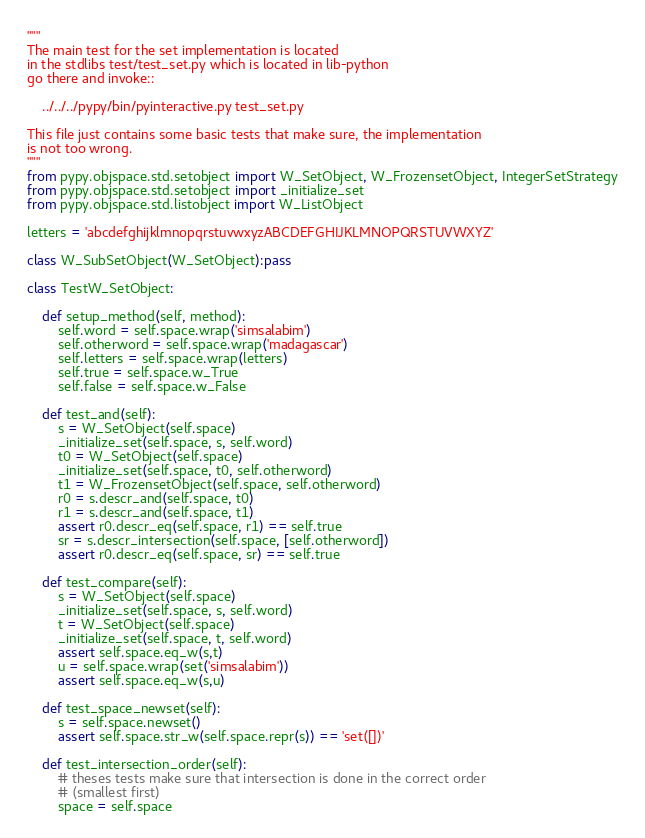Convert code to text. <code><loc_0><loc_0><loc_500><loc_500><_Python_>"""
The main test for the set implementation is located
in the stdlibs test/test_set.py which is located in lib-python
go there and invoke::

    ../../../pypy/bin/pyinteractive.py test_set.py

This file just contains some basic tests that make sure, the implementation
is not too wrong.
"""
from pypy.objspace.std.setobject import W_SetObject, W_FrozensetObject, IntegerSetStrategy
from pypy.objspace.std.setobject import _initialize_set
from pypy.objspace.std.listobject import W_ListObject

letters = 'abcdefghijklmnopqrstuvwxyzABCDEFGHIJKLMNOPQRSTUVWXYZ'

class W_SubSetObject(W_SetObject):pass

class TestW_SetObject:

    def setup_method(self, method):
        self.word = self.space.wrap('simsalabim')
        self.otherword = self.space.wrap('madagascar')
        self.letters = self.space.wrap(letters)
        self.true = self.space.w_True
        self.false = self.space.w_False

    def test_and(self):
        s = W_SetObject(self.space)
        _initialize_set(self.space, s, self.word)
        t0 = W_SetObject(self.space)
        _initialize_set(self.space, t0, self.otherword)
        t1 = W_FrozensetObject(self.space, self.otherword)
        r0 = s.descr_and(self.space, t0)
        r1 = s.descr_and(self.space, t1)
        assert r0.descr_eq(self.space, r1) == self.true
        sr = s.descr_intersection(self.space, [self.otherword])
        assert r0.descr_eq(self.space, sr) == self.true

    def test_compare(self):
        s = W_SetObject(self.space)
        _initialize_set(self.space, s, self.word)
        t = W_SetObject(self.space)
        _initialize_set(self.space, t, self.word)
        assert self.space.eq_w(s,t)
        u = self.space.wrap(set('simsalabim'))
        assert self.space.eq_w(s,u)

    def test_space_newset(self):
        s = self.space.newset()
        assert self.space.str_w(self.space.repr(s)) == 'set([])'

    def test_intersection_order(self):
        # theses tests make sure that intersection is done in the correct order
        # (smallest first)
        space = self.space</code> 